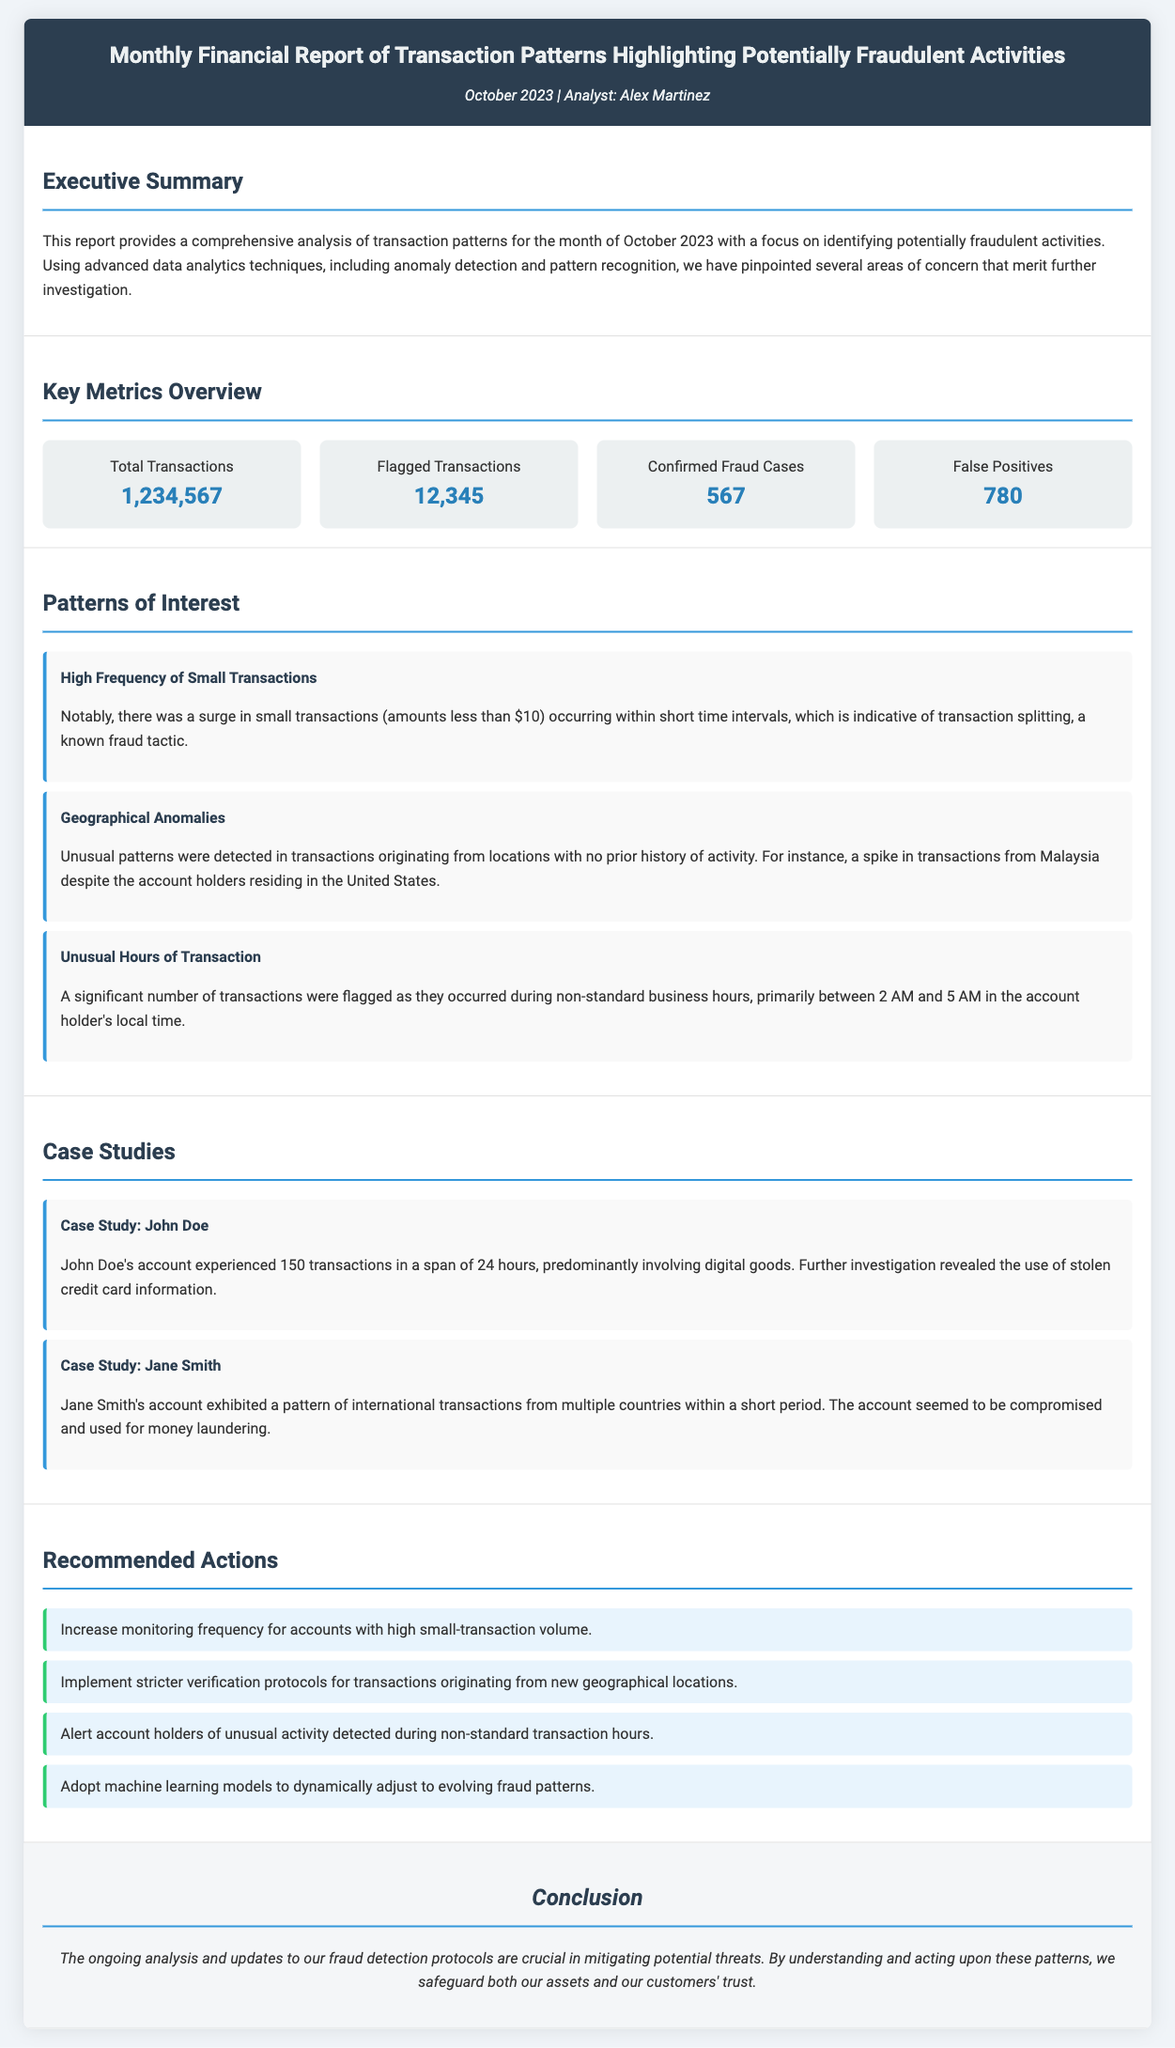What is the total number of transactions? The total number of transactions listed in the document under "Key Metrics Overview" is 1,234,567.
Answer: 1,234,567 How many transactions were flagged? The number of flagged transactions mentioned in the "Key Metrics Overview" is 12,345.
Answer: 12,345 What is the confirmed fraud cases count? The confirmed fraud cases count provided in the report is 567, as stated in the "Key Metrics Overview".
Answer: 567 Which pattern indicates transaction splitting? The "High Frequency of Small Transactions" pattern is indicative of transaction splitting, according to the "Patterns of Interest".
Answer: High Frequency of Small Transactions What was revealed in Case Study: John Doe? The investigation of John Doe's account revealed the use of stolen credit card information.
Answer: Use of stolen credit card information Which action is suggested for accounts with high small-transaction volume? The recommended action is to increase monitoring frequency for those accounts.
Answer: Increase monitoring frequency What was the unusual time frame for flagged transactions? The significant number of flagged transactions were during non-standard business hours, primarily between 2 AM and 5 AM.
Answer: 2 AM and 5 AM What recommendation involves machine learning? The document recommends adopting machine learning models to dynamically adjust to evolving fraud patterns.
Answer: Adopting machine learning models What is the purpose of this report? The report's purpose is to provide a comprehensive analysis of transaction patterns to identify potentially fraudulent activities.
Answer: Identify potentially fraudulent activities 